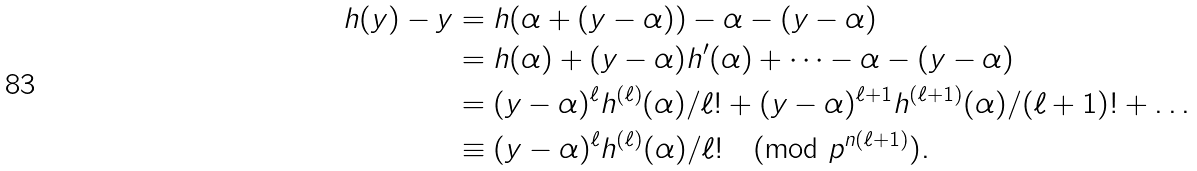<formula> <loc_0><loc_0><loc_500><loc_500>h ( y ) - y & = h ( \alpha + ( y - \alpha ) ) - \alpha - ( y - \alpha ) \\ & = h ( \alpha ) + ( y - \alpha ) h ^ { \prime } ( \alpha ) + \dots - \alpha - ( y - \alpha ) \\ & = ( y - \alpha ) ^ { \ell } h ^ { ( \ell ) } ( \alpha ) / \ell ! + ( y - \alpha ) ^ { \ell + 1 } h ^ { ( \ell + 1 ) } ( \alpha ) / ( \ell + 1 ) ! + \dots \\ & \equiv ( y - \alpha ) ^ { \ell } h ^ { ( \ell ) } ( \alpha ) / \ell ! \pmod { p ^ { n ( \ell + 1 ) } } .</formula> 